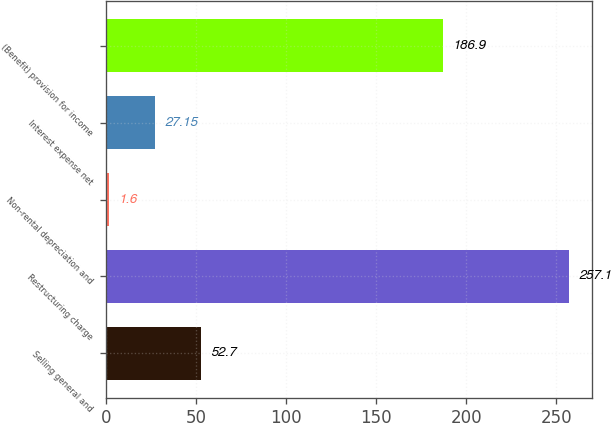Convert chart to OTSL. <chart><loc_0><loc_0><loc_500><loc_500><bar_chart><fcel>Selling general and<fcel>Restructuring charge<fcel>Non-rental depreciation and<fcel>Interest expense net<fcel>(Benefit) provision for income<nl><fcel>52.7<fcel>257.1<fcel>1.6<fcel>27.15<fcel>186.9<nl></chart> 